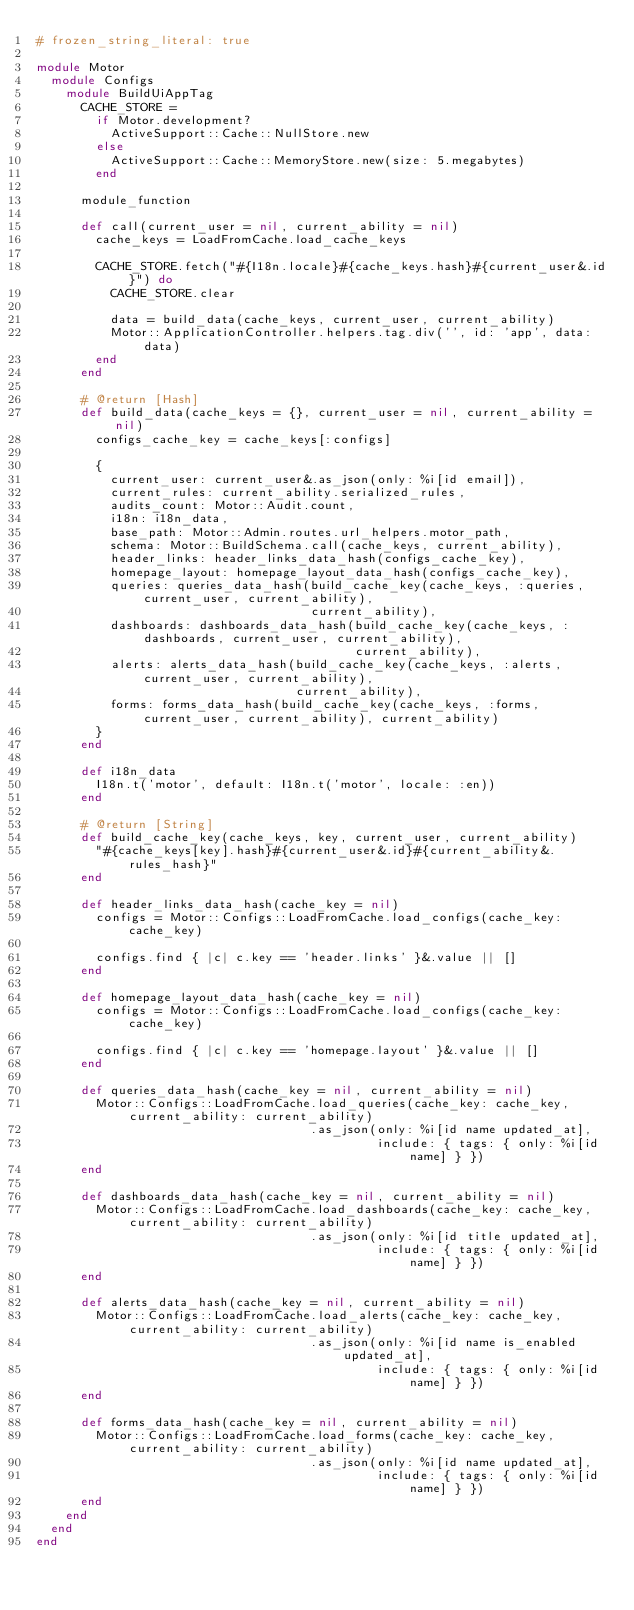Convert code to text. <code><loc_0><loc_0><loc_500><loc_500><_Ruby_># frozen_string_literal: true

module Motor
  module Configs
    module BuildUiAppTag
      CACHE_STORE =
        if Motor.development?
          ActiveSupport::Cache::NullStore.new
        else
          ActiveSupport::Cache::MemoryStore.new(size: 5.megabytes)
        end

      module_function

      def call(current_user = nil, current_ability = nil)
        cache_keys = LoadFromCache.load_cache_keys

        CACHE_STORE.fetch("#{I18n.locale}#{cache_keys.hash}#{current_user&.id}") do
          CACHE_STORE.clear

          data = build_data(cache_keys, current_user, current_ability)
          Motor::ApplicationController.helpers.tag.div('', id: 'app', data: data)
        end
      end

      # @return [Hash]
      def build_data(cache_keys = {}, current_user = nil, current_ability = nil)
        configs_cache_key = cache_keys[:configs]

        {
          current_user: current_user&.as_json(only: %i[id email]),
          current_rules: current_ability.serialized_rules,
          audits_count: Motor::Audit.count,
          i18n: i18n_data,
          base_path: Motor::Admin.routes.url_helpers.motor_path,
          schema: Motor::BuildSchema.call(cache_keys, current_ability),
          header_links: header_links_data_hash(configs_cache_key),
          homepage_layout: homepage_layout_data_hash(configs_cache_key),
          queries: queries_data_hash(build_cache_key(cache_keys, :queries, current_user, current_ability),
                                     current_ability),
          dashboards: dashboards_data_hash(build_cache_key(cache_keys, :dashboards, current_user, current_ability),
                                           current_ability),
          alerts: alerts_data_hash(build_cache_key(cache_keys, :alerts, current_user, current_ability),
                                   current_ability),
          forms: forms_data_hash(build_cache_key(cache_keys, :forms, current_user, current_ability), current_ability)
        }
      end

      def i18n_data
        I18n.t('motor', default: I18n.t('motor', locale: :en))
      end

      # @return [String]
      def build_cache_key(cache_keys, key, current_user, current_ability)
        "#{cache_keys[key].hash}#{current_user&.id}#{current_ability&.rules_hash}"
      end

      def header_links_data_hash(cache_key = nil)
        configs = Motor::Configs::LoadFromCache.load_configs(cache_key: cache_key)

        configs.find { |c| c.key == 'header.links' }&.value || []
      end

      def homepage_layout_data_hash(cache_key = nil)
        configs = Motor::Configs::LoadFromCache.load_configs(cache_key: cache_key)

        configs.find { |c| c.key == 'homepage.layout' }&.value || []
      end

      def queries_data_hash(cache_key = nil, current_ability = nil)
        Motor::Configs::LoadFromCache.load_queries(cache_key: cache_key, current_ability: current_ability)
                                     .as_json(only: %i[id name updated_at],
                                              include: { tags: { only: %i[id name] } })
      end

      def dashboards_data_hash(cache_key = nil, current_ability = nil)
        Motor::Configs::LoadFromCache.load_dashboards(cache_key: cache_key, current_ability: current_ability)
                                     .as_json(only: %i[id title updated_at],
                                              include: { tags: { only: %i[id name] } })
      end

      def alerts_data_hash(cache_key = nil, current_ability = nil)
        Motor::Configs::LoadFromCache.load_alerts(cache_key: cache_key, current_ability: current_ability)
                                     .as_json(only: %i[id name is_enabled updated_at],
                                              include: { tags: { only: %i[id name] } })
      end

      def forms_data_hash(cache_key = nil, current_ability = nil)
        Motor::Configs::LoadFromCache.load_forms(cache_key: cache_key, current_ability: current_ability)
                                     .as_json(only: %i[id name updated_at],
                                              include: { tags: { only: %i[id name] } })
      end
    end
  end
end
</code> 